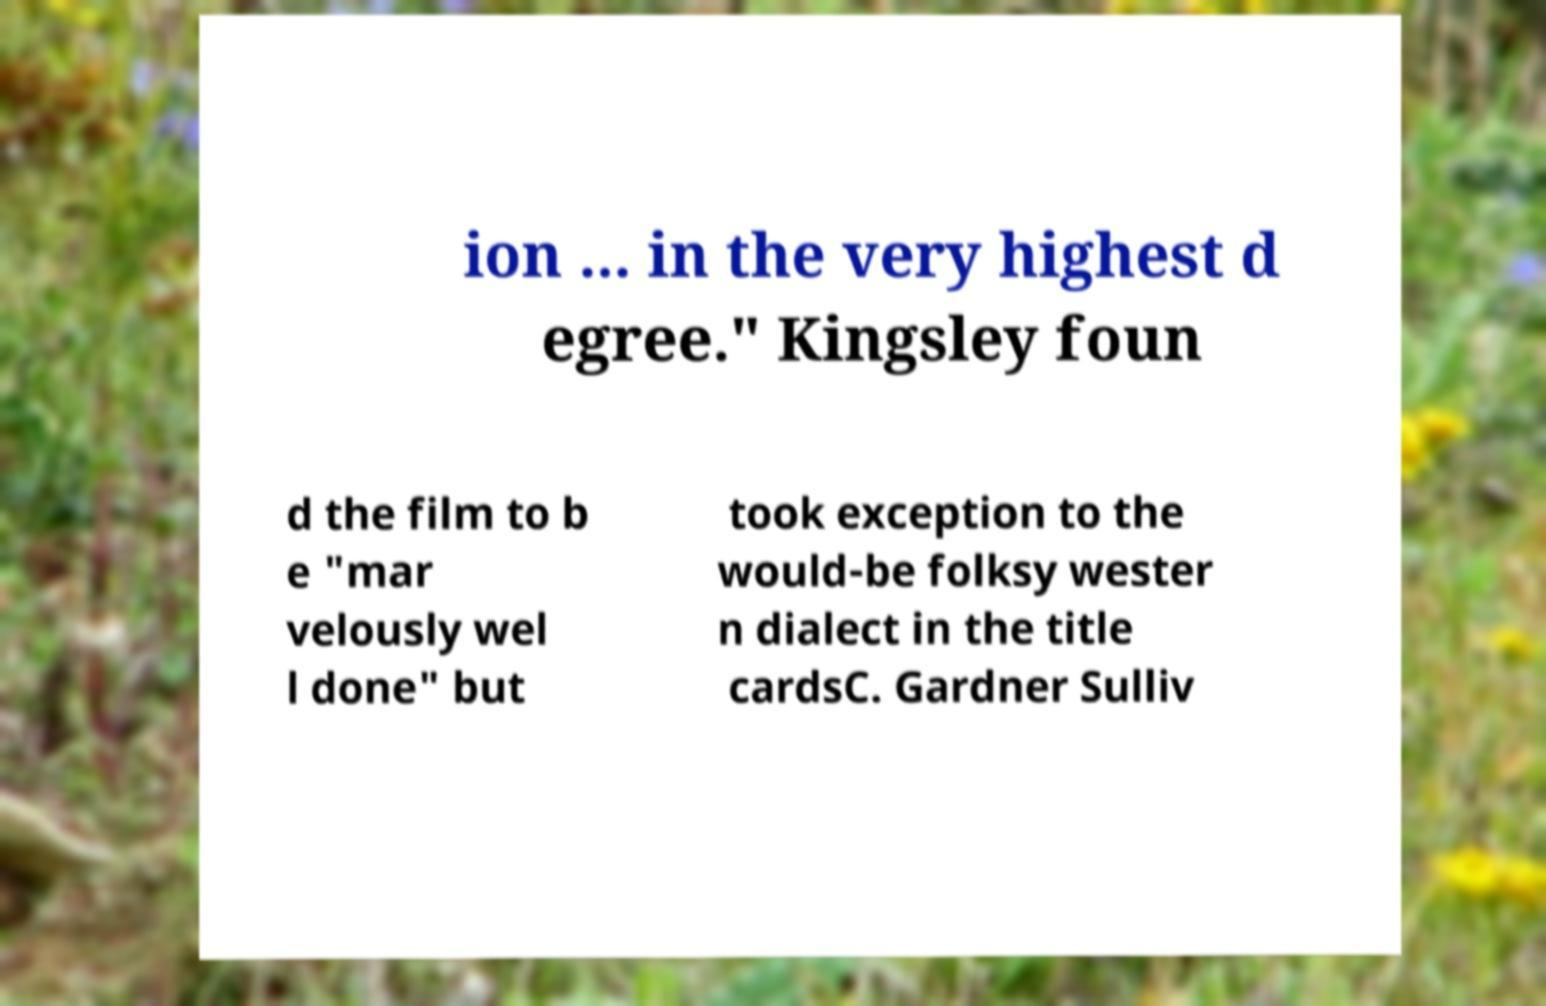There's text embedded in this image that I need extracted. Can you transcribe it verbatim? ion ... in the very highest d egree." Kingsley foun d the film to b e "mar velously wel l done" but took exception to the would-be folksy wester n dialect in the title cardsC. Gardner Sulliv 